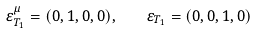<formula> <loc_0><loc_0><loc_500><loc_500>\varepsilon ^ { \mu } _ { T _ { 1 } } = ( 0 , 1 , 0 , 0 ) , \quad \varepsilon _ { T _ { 1 } } = ( 0 , 0 , 1 , 0 )</formula> 